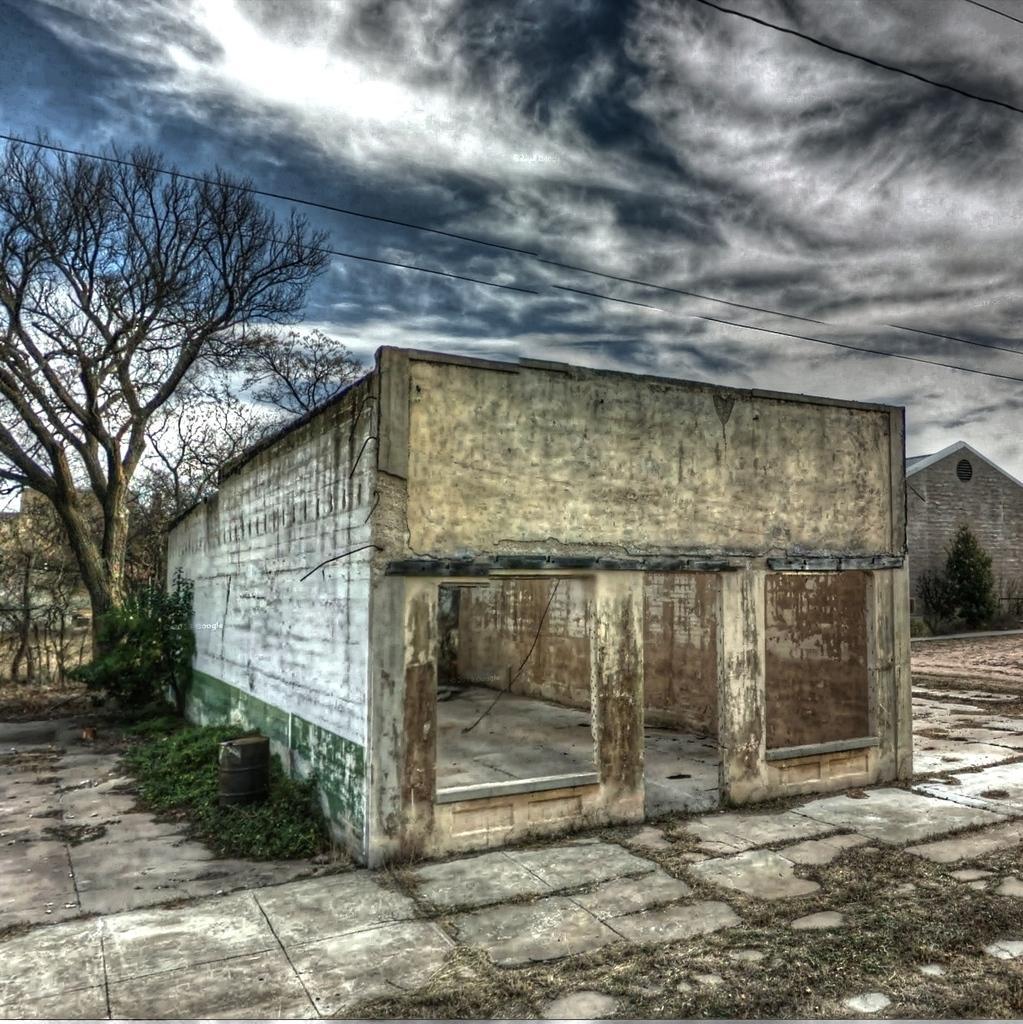Describe this image in one or two sentences. Sky is cloudy. Here we can see buildings, plants and trees. This is drum. 